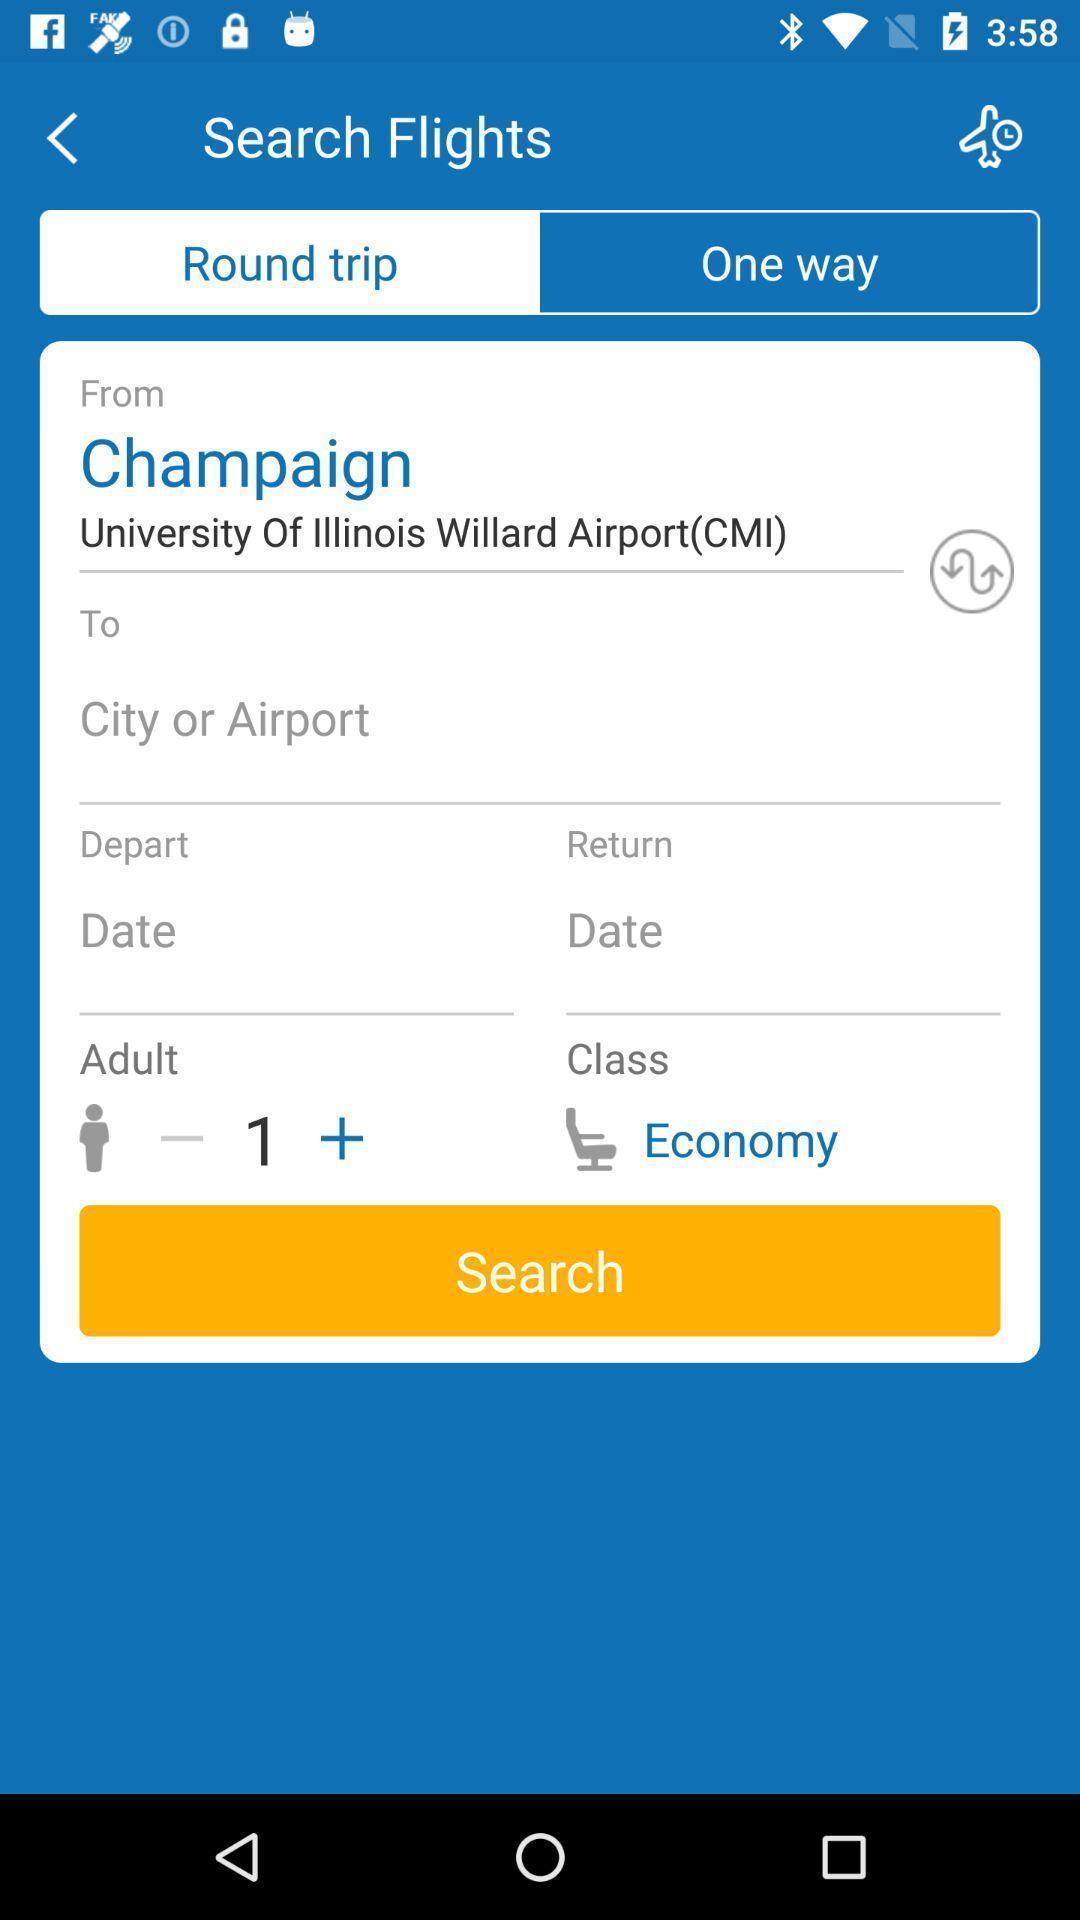What details can you identify in this image? Page to search flights entering location and details. 